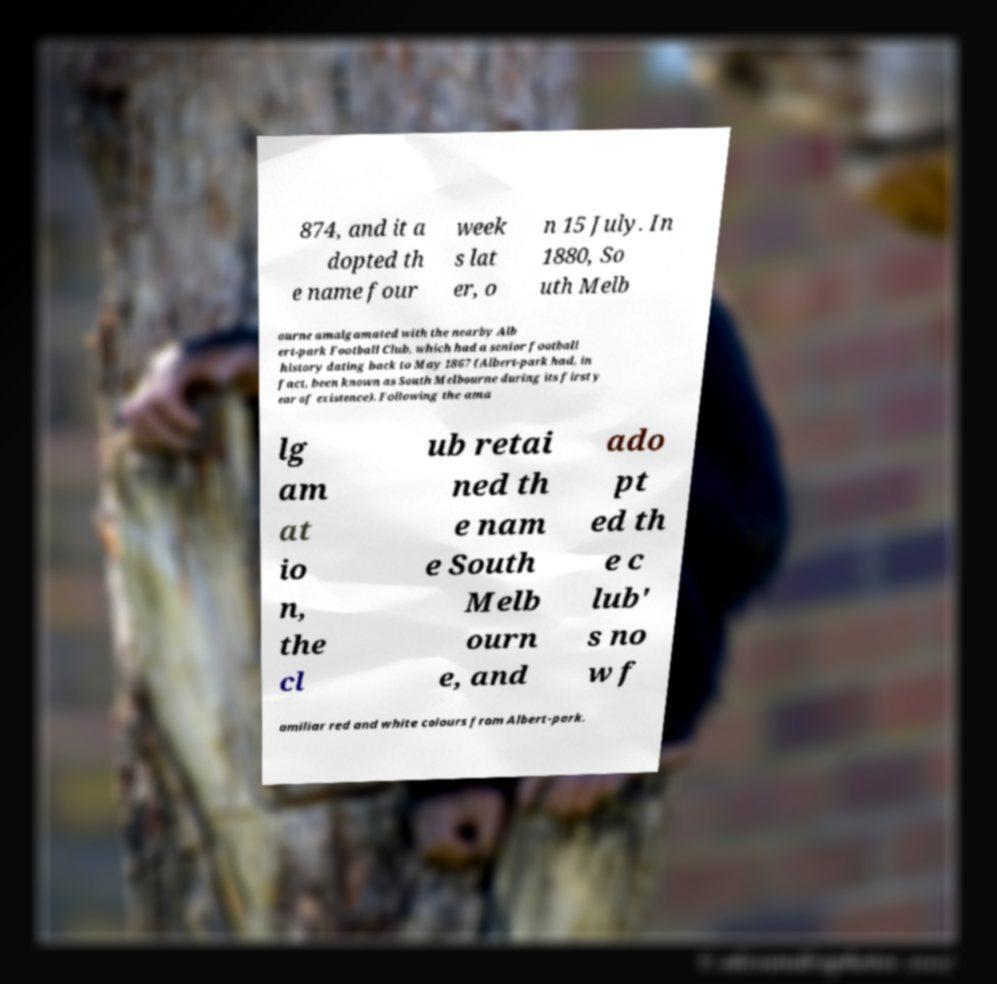What messages or text are displayed in this image? I need them in a readable, typed format. 874, and it a dopted th e name four week s lat er, o n 15 July. In 1880, So uth Melb ourne amalgamated with the nearby Alb ert-park Football Club, which had a senior football history dating back to May 1867 (Albert-park had, in fact, been known as South Melbourne during its first y ear of existence). Following the ama lg am at io n, the cl ub retai ned th e nam e South Melb ourn e, and ado pt ed th e c lub' s no w f amiliar red and white colours from Albert-park. 